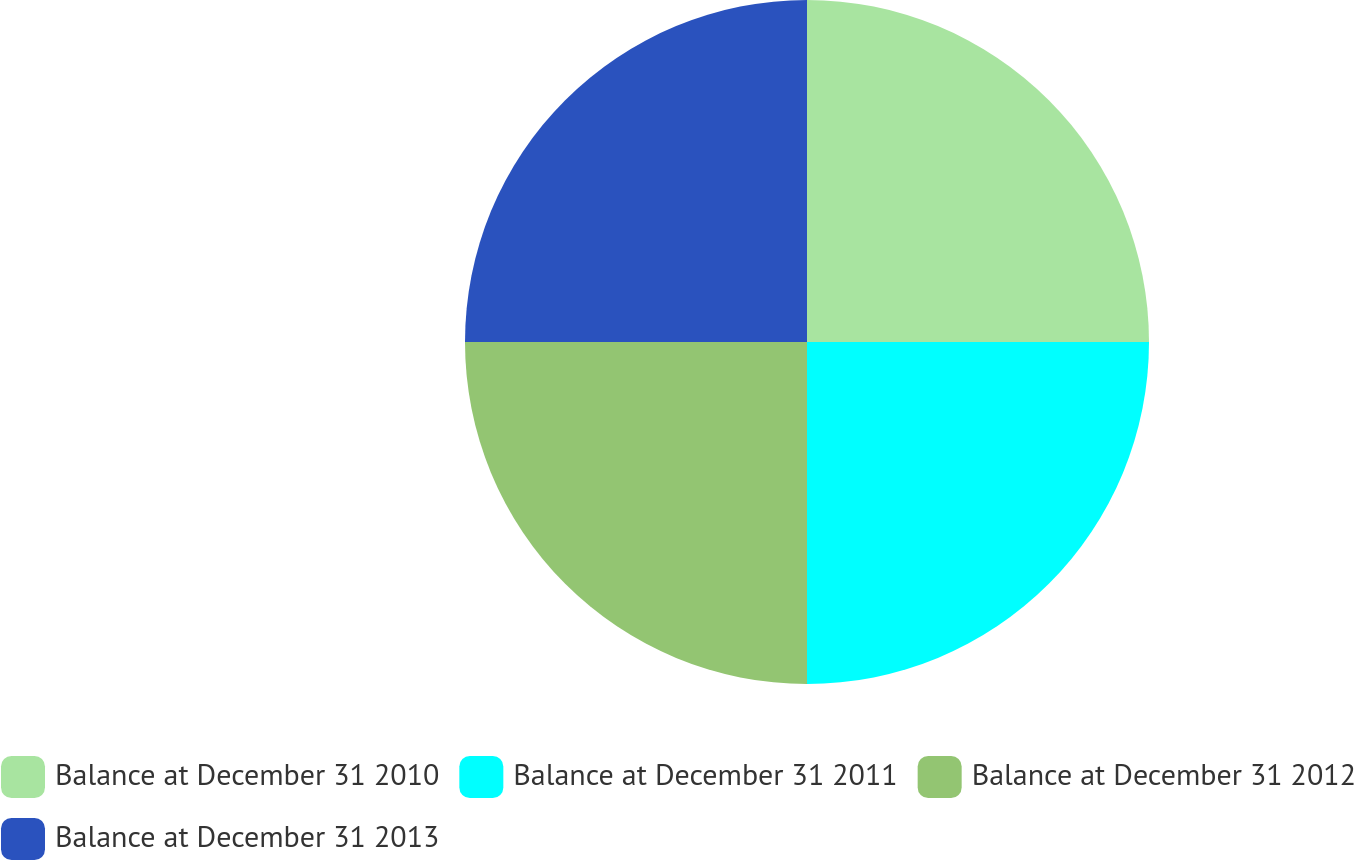Convert chart to OTSL. <chart><loc_0><loc_0><loc_500><loc_500><pie_chart><fcel>Balance at December 31 2010<fcel>Balance at December 31 2011<fcel>Balance at December 31 2012<fcel>Balance at December 31 2013<nl><fcel>25.0%<fcel>25.0%<fcel>25.0%<fcel>25.0%<nl></chart> 